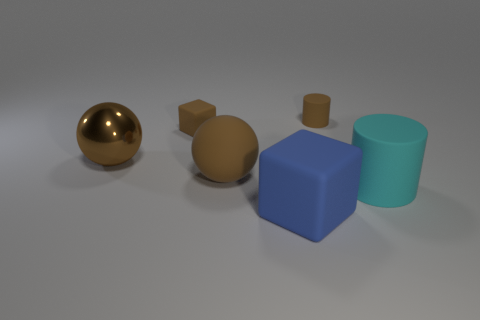Add 2 tiny brown metal cylinders. How many objects exist? 8 Subtract all cubes. How many objects are left? 4 Add 6 big purple matte things. How many big purple matte things exist? 6 Subtract 1 blue blocks. How many objects are left? 5 Subtract all tiny brown rubber cylinders. Subtract all gray shiny things. How many objects are left? 5 Add 5 brown objects. How many brown objects are left? 9 